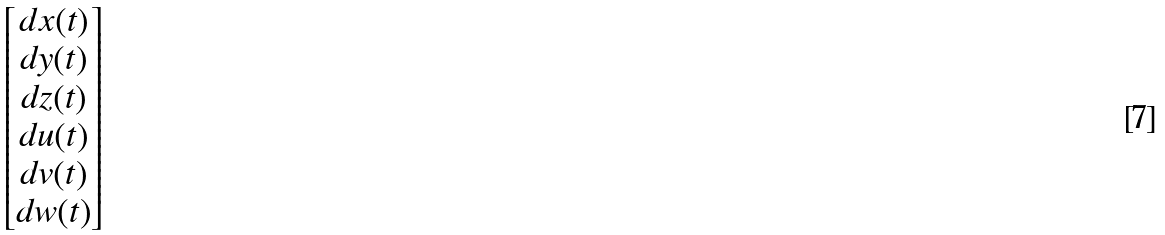Convert formula to latex. <formula><loc_0><loc_0><loc_500><loc_500>\begin{bmatrix} d x ( t ) \\ d y ( t ) \\ d z ( t ) \\ d u ( t ) \\ d v ( t ) \\ d w ( t ) \end{bmatrix}</formula> 